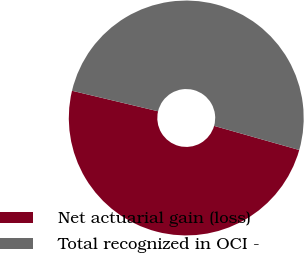Convert chart. <chart><loc_0><loc_0><loc_500><loc_500><pie_chart><fcel>Net actuarial gain (loss)<fcel>Total recognized in OCI -<nl><fcel>49.33%<fcel>50.67%<nl></chart> 